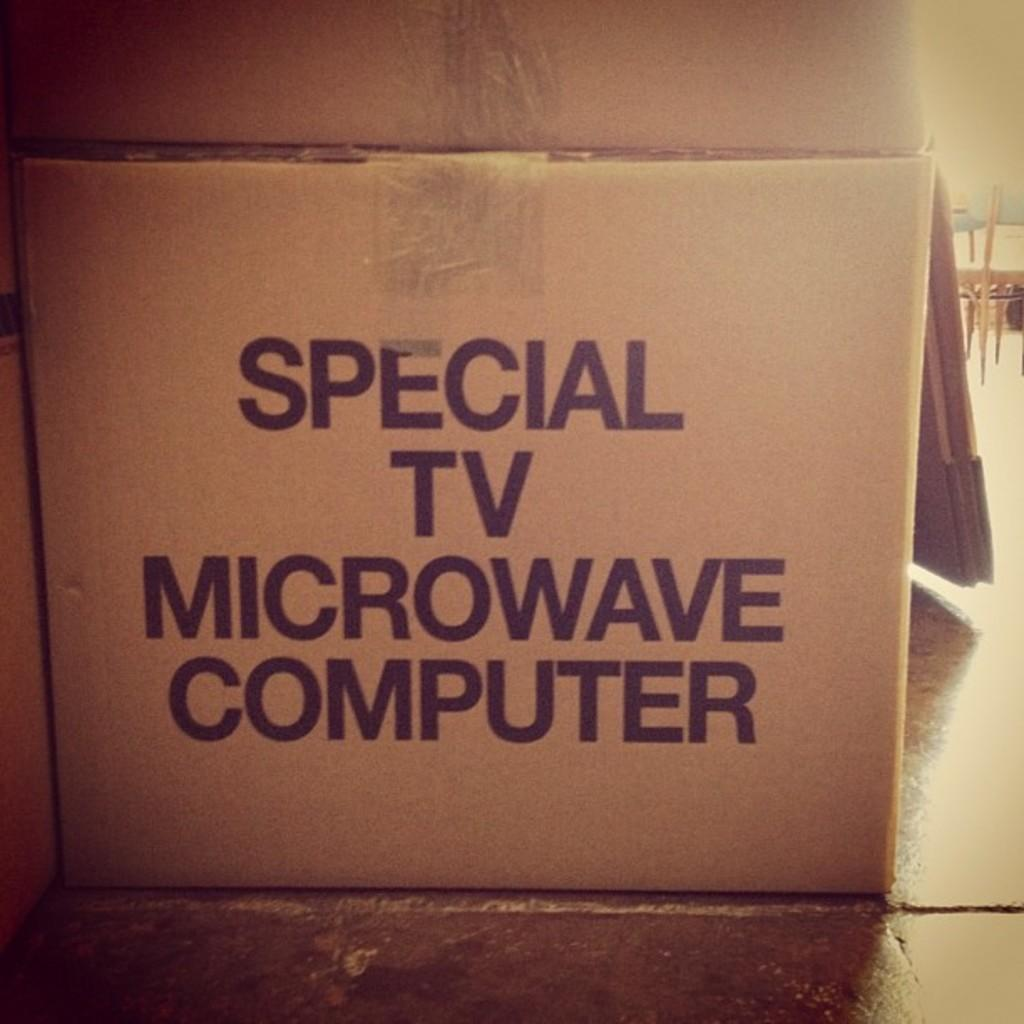<image>
Relay a brief, clear account of the picture shown. a brown cardboard box for special tv microwave computers 